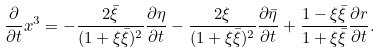Convert formula to latex. <formula><loc_0><loc_0><loc_500><loc_500>\frac { \partial } { \partial t } x ^ { 3 } = - \frac { 2 \bar { \xi } } { ( 1 + \xi \bar { \xi } ) ^ { 2 } } \frac { \partial \eta } { \partial t } - \frac { 2 \xi } { ( 1 + \xi \bar { \xi } ) ^ { 2 } } \frac { \partial \bar { \eta } } { \partial t } + \frac { 1 - \xi \bar { \xi } } { 1 + \xi \bar { \xi } } \frac { \partial r } { \partial t } .</formula> 